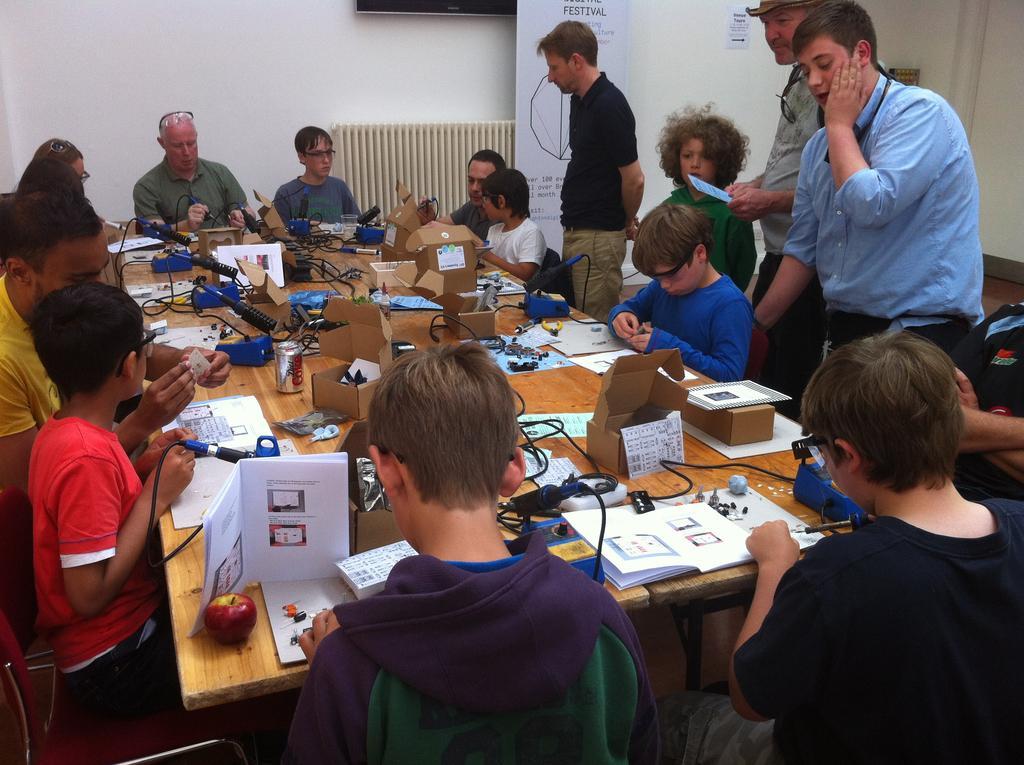Please provide a concise description of this image. In this Image I see number of people in which most of them are sitting on chairs and few of them are standing. I can also see there is a table in front of them on which there are many things. In the background I see the wall, a banner and a paper over here. 